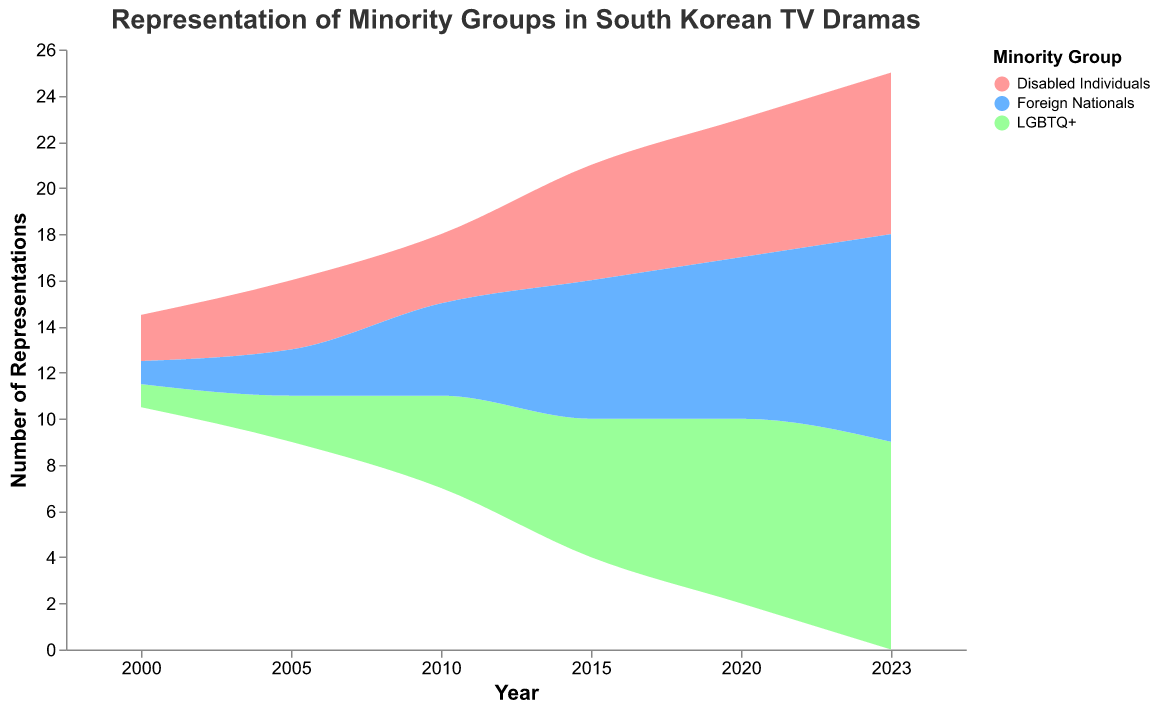Which group had the highest number of representations in 2023? The graph shows that Foreign Nationals and LGBTQ+ both had the highest number of representations in 2023, each with 9.
Answer: Foreign Nationals and LGBTQ+ How many total representations were there in 2010? Sum the number of representations for each minority group in 2010: LGBTQ+ (4) + Disabled Individuals (3) + Foreign Nationals (4).
Answer: 11 Which group shows the most significant increase in representations from 2000 to 2023? Compare the representations of each group: LGBTQ+ increased from 1 to 9 (+8), Disabled Individuals from 2 to 7 (+5), and Foreign Nationals from 1 to 9 (+8). Both LGBTQ+ and Foreign Nationals show significant increase.
Answer: LGBTQ+ and Foreign Nationals What is the overall trend in the number of representations for Disabled Individuals? The graph shows a steady increase over the years: from 2 in 2000, 3 in 2005 and 2010, to 5 in 2015, 6 in 2020, and 7 in 2023.
Answer: Increasing In which year did the representation of LGBTQ+ surpass that of Disabled Individuals? By examining the graph, it appears in 2010 when LGBTQ+ has 4 and Disabled Individuals has 3.
Answer: 2010 How did the representation of Foreign Nationals change between 2015 and 2020? The number of representations increased from 6 in 2015 to 7 in 2020.
Answer: Increased by 1 What is the title of the graph? The title of the graph is displayed at the top.
Answer: Representation of Minority Groups in South Korean TV Dramas How does the representation of Foreign Nationals in 2005 compare with that in 2023? In 2005, Foreign Nationals had 2 representations, while in 2023, it had 9 representations.
Answer: Increased by 7 Which group had the least number of representations in 2005? The graph shows that both LGBTQ+ and Foreign Nationals had 2 representations in 2005, fewer than Disabled Individuals (3).
Answer: LGBTQ+ and Foreign Nationals What is the sum of representations for all groups in 2020? Sum the number of representations for each group in 2020: LGBTQ+ (8), Disabled Individuals (6), Foreign Nationals (7).
Answer: 21 